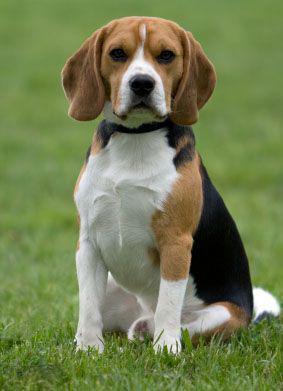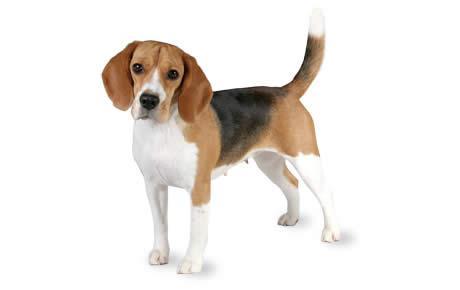The first image is the image on the left, the second image is the image on the right. For the images shown, is this caption "At least one dog is sitting." true? Answer yes or no. Yes. 